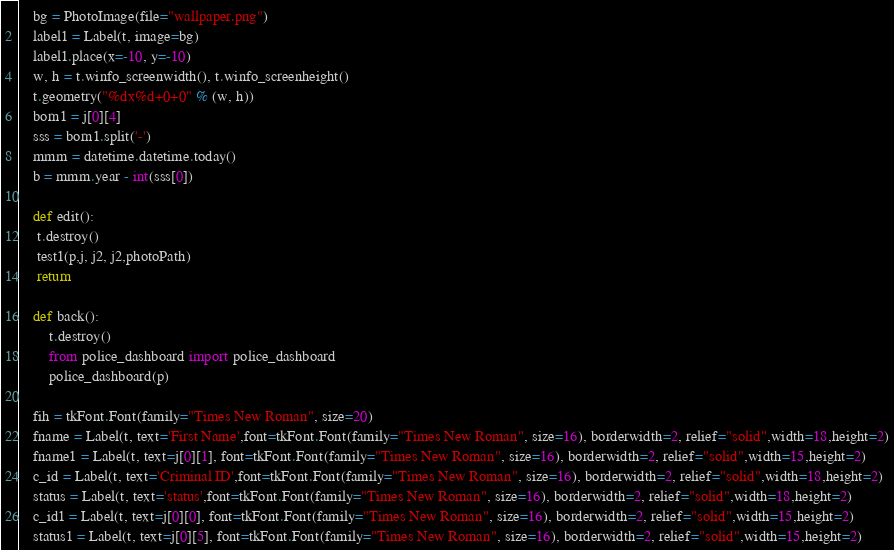<code> <loc_0><loc_0><loc_500><loc_500><_Python_>    bg = PhotoImage(file="wallpaper.png")
    label1 = Label(t, image=bg)
    label1.place(x=-10, y=-10)
    w, h = t.winfo_screenwidth(), t.winfo_screenheight()
    t.geometry("%dx%d+0+0" % (w, h))
    born1 = j[0][4]
    sss = born1.split('-')
    mmm = datetime.datetime.today()
    b = mmm.year - int(sss[0])

    def edit():
     t.destroy()
     test1(p,j, j2, j2,photoPath)
     return

    def back():
        t.destroy()
        from police_dashboard import police_dashboard
        police_dashboard(p)

    fih = tkFont.Font(family="Times New Roman", size=20)
    fname = Label(t, text='First Name',font=tkFont.Font(family="Times New Roman", size=16), borderwidth=2, relief="solid",width=18,height=2)
    fname1 = Label(t, text=j[0][1], font=tkFont.Font(family="Times New Roman", size=16), borderwidth=2, relief="solid",width=15,height=2)
    c_id = Label(t, text='Criminal ID',font=tkFont.Font(family="Times New Roman", size=16), borderwidth=2, relief="solid",width=18,height=2)
    status = Label(t, text='status',font=tkFont.Font(family="Times New Roman", size=16), borderwidth=2, relief="solid",width=18,height=2)
    c_id1 = Label(t, text=j[0][0], font=tkFont.Font(family="Times New Roman", size=16), borderwidth=2, relief="solid",width=15,height=2)
    status1 = Label(t, text=j[0][5], font=tkFont.Font(family="Times New Roman", size=16), borderwidth=2, relief="solid",width=15,height=2)</code> 